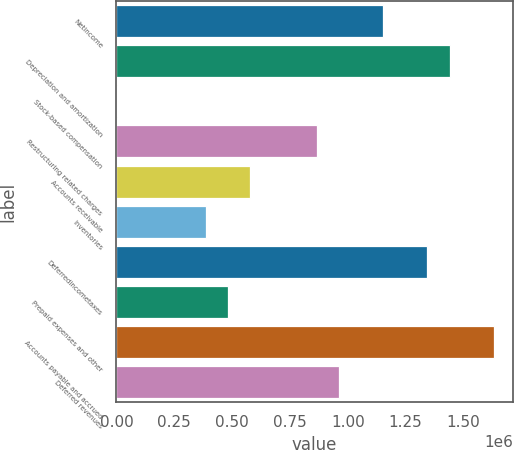Convert chart to OTSL. <chart><loc_0><loc_0><loc_500><loc_500><bar_chart><fcel>Netincome<fcel>Depreciation and amortization<fcel>Stock-based compensation<fcel>Restructuring related charges<fcel>Accounts receivable<fcel>Inventories<fcel>Deferredincometaxes<fcel>Prepaid expenses and other<fcel>Accounts payable and accrued<fcel>Deferred revenues<nl><fcel>1.15213e+06<fcel>1.43947e+06<fcel>2753<fcel>864784<fcel>577440<fcel>385878<fcel>1.34369e+06<fcel>481659<fcel>1.63103e+06<fcel>960565<nl></chart> 